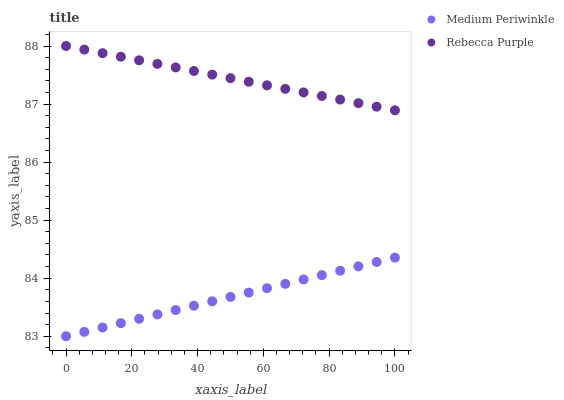Does Medium Periwinkle have the minimum area under the curve?
Answer yes or no. Yes. Does Rebecca Purple have the maximum area under the curve?
Answer yes or no. Yes. Does Rebecca Purple have the minimum area under the curve?
Answer yes or no. No. Is Rebecca Purple the smoothest?
Answer yes or no. Yes. Is Medium Periwinkle the roughest?
Answer yes or no. Yes. Is Rebecca Purple the roughest?
Answer yes or no. No. Does Medium Periwinkle have the lowest value?
Answer yes or no. Yes. Does Rebecca Purple have the lowest value?
Answer yes or no. No. Does Rebecca Purple have the highest value?
Answer yes or no. Yes. Is Medium Periwinkle less than Rebecca Purple?
Answer yes or no. Yes. Is Rebecca Purple greater than Medium Periwinkle?
Answer yes or no. Yes. Does Medium Periwinkle intersect Rebecca Purple?
Answer yes or no. No. 